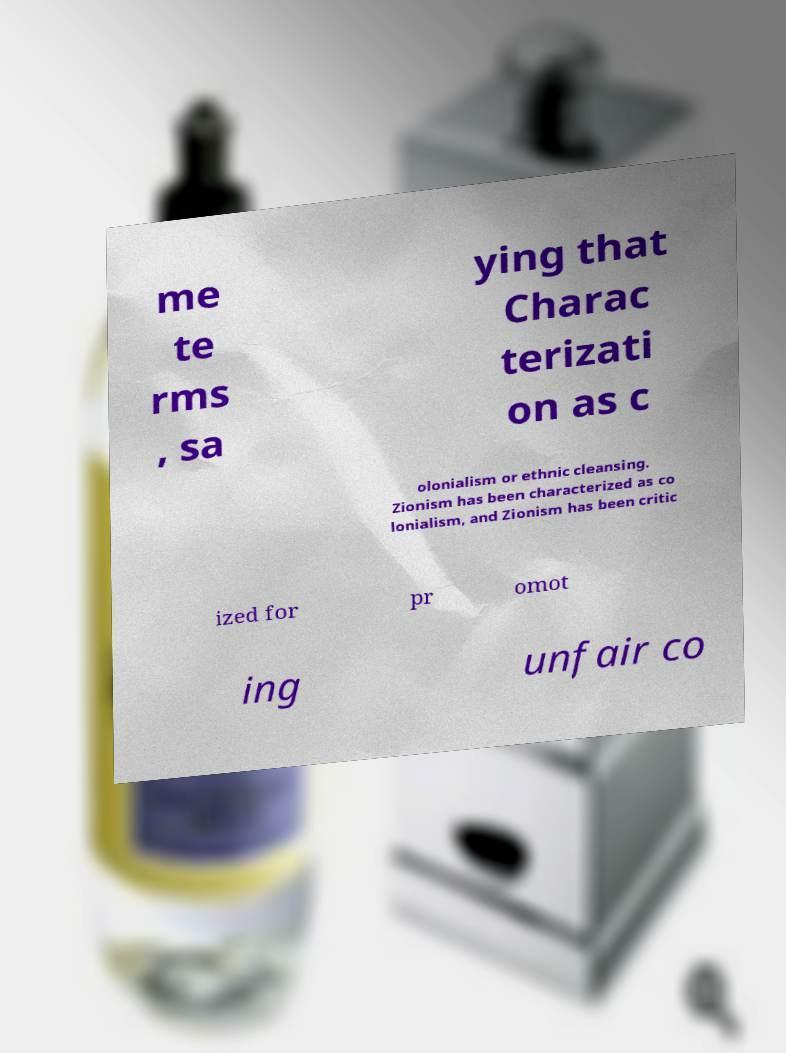There's text embedded in this image that I need extracted. Can you transcribe it verbatim? me te rms , sa ying that Charac terizati on as c olonialism or ethnic cleansing. Zionism has been characterized as co lonialism, and Zionism has been critic ized for pr omot ing unfair co 